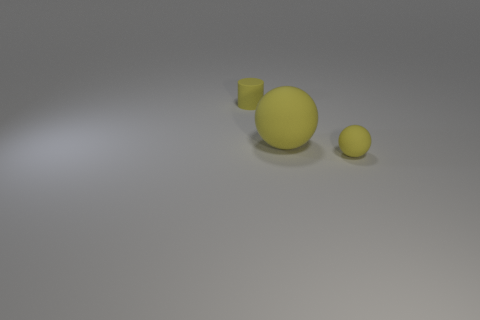Add 1 big cyan metallic cylinders. How many objects exist? 4 Subtract all balls. How many objects are left? 1 Add 1 small yellow matte spheres. How many small yellow matte spheres are left? 2 Add 1 small yellow metal cylinders. How many small yellow metal cylinders exist? 1 Subtract 2 yellow spheres. How many objects are left? 1 Subtract all big yellow balls. Subtract all matte cylinders. How many objects are left? 1 